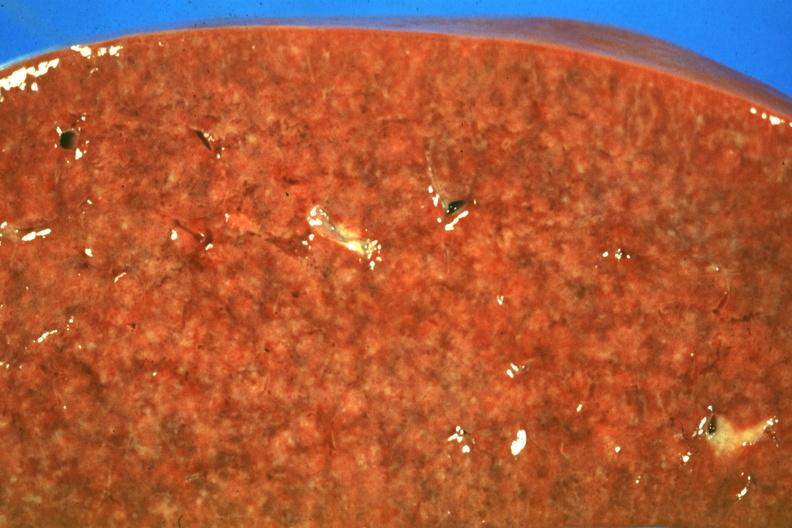does this image show cut surface granulomas faint but there?
Answer the question using a single word or phrase. Yes 